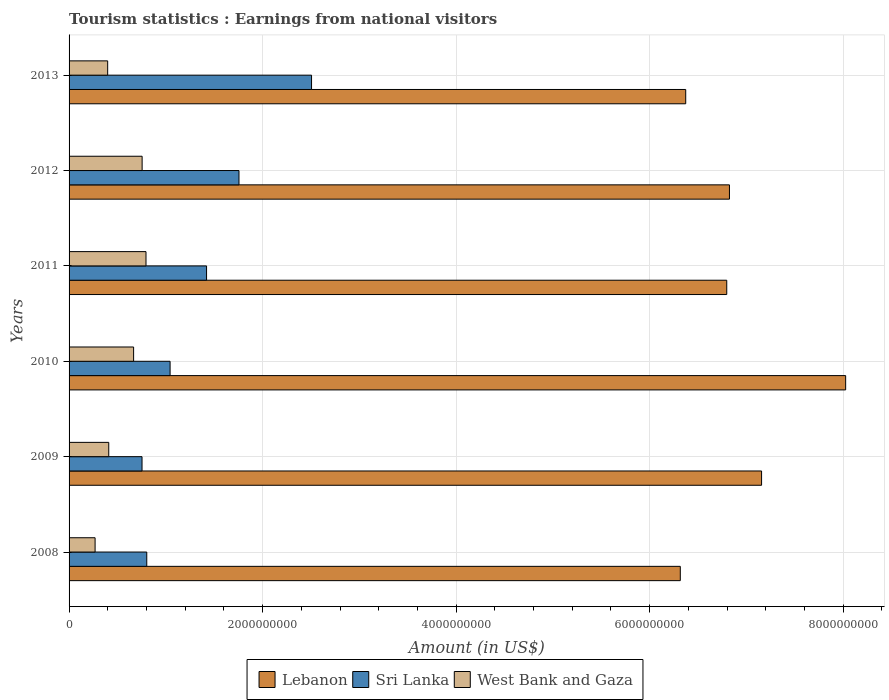Are the number of bars per tick equal to the number of legend labels?
Ensure brevity in your answer.  Yes. How many bars are there on the 4th tick from the top?
Your answer should be compact. 3. How many bars are there on the 2nd tick from the bottom?
Your answer should be very brief. 3. In how many cases, is the number of bars for a given year not equal to the number of legend labels?
Give a very brief answer. 0. What is the earnings from national visitors in West Bank and Gaza in 2012?
Provide a succinct answer. 7.55e+08. Across all years, what is the maximum earnings from national visitors in Lebanon?
Make the answer very short. 8.03e+09. Across all years, what is the minimum earnings from national visitors in Sri Lanka?
Your response must be concise. 7.54e+08. In which year was the earnings from national visitors in Lebanon maximum?
Ensure brevity in your answer.  2010. In which year was the earnings from national visitors in Lebanon minimum?
Make the answer very short. 2008. What is the total earnings from national visitors in Sri Lanka in the graph?
Provide a succinct answer. 8.28e+09. What is the difference between the earnings from national visitors in Sri Lanka in 2009 and that in 2013?
Provide a succinct answer. -1.75e+09. What is the difference between the earnings from national visitors in West Bank and Gaza in 2009 and the earnings from national visitors in Sri Lanka in 2012?
Ensure brevity in your answer.  -1.35e+09. What is the average earnings from national visitors in West Bank and Gaza per year?
Offer a terse response. 5.49e+08. In the year 2012, what is the difference between the earnings from national visitors in West Bank and Gaza and earnings from national visitors in Sri Lanka?
Keep it short and to the point. -1.00e+09. In how many years, is the earnings from national visitors in Sri Lanka greater than 1200000000 US$?
Your answer should be very brief. 3. What is the ratio of the earnings from national visitors in Lebanon in 2009 to that in 2013?
Keep it short and to the point. 1.12. Is the earnings from national visitors in Sri Lanka in 2010 less than that in 2013?
Ensure brevity in your answer.  Yes. What is the difference between the highest and the second highest earnings from national visitors in Sri Lanka?
Your answer should be compact. 7.50e+08. What is the difference between the highest and the lowest earnings from national visitors in West Bank and Gaza?
Offer a very short reply. 5.26e+08. In how many years, is the earnings from national visitors in West Bank and Gaza greater than the average earnings from national visitors in West Bank and Gaza taken over all years?
Make the answer very short. 3. What does the 2nd bar from the top in 2010 represents?
Give a very brief answer. Sri Lanka. What does the 1st bar from the bottom in 2011 represents?
Ensure brevity in your answer.  Lebanon. Is it the case that in every year, the sum of the earnings from national visitors in West Bank and Gaza and earnings from national visitors in Sri Lanka is greater than the earnings from national visitors in Lebanon?
Offer a very short reply. No. How many bars are there?
Your response must be concise. 18. Are all the bars in the graph horizontal?
Offer a very short reply. Yes. Are the values on the major ticks of X-axis written in scientific E-notation?
Keep it short and to the point. No. Where does the legend appear in the graph?
Make the answer very short. Bottom center. How are the legend labels stacked?
Your answer should be very brief. Horizontal. What is the title of the graph?
Provide a short and direct response. Tourism statistics : Earnings from national visitors. What is the label or title of the X-axis?
Provide a short and direct response. Amount (in US$). What is the Amount (in US$) in Lebanon in 2008?
Keep it short and to the point. 6.32e+09. What is the Amount (in US$) in Sri Lanka in 2008?
Your response must be concise. 8.03e+08. What is the Amount (in US$) in West Bank and Gaza in 2008?
Give a very brief answer. 2.69e+08. What is the Amount (in US$) of Lebanon in 2009?
Your response must be concise. 7.16e+09. What is the Amount (in US$) in Sri Lanka in 2009?
Your answer should be compact. 7.54e+08. What is the Amount (in US$) in West Bank and Gaza in 2009?
Keep it short and to the point. 4.10e+08. What is the Amount (in US$) in Lebanon in 2010?
Your answer should be very brief. 8.03e+09. What is the Amount (in US$) of Sri Lanka in 2010?
Your answer should be compact. 1.04e+09. What is the Amount (in US$) of West Bank and Gaza in 2010?
Make the answer very short. 6.67e+08. What is the Amount (in US$) in Lebanon in 2011?
Make the answer very short. 6.80e+09. What is the Amount (in US$) in Sri Lanka in 2011?
Provide a succinct answer. 1.42e+09. What is the Amount (in US$) of West Bank and Gaza in 2011?
Offer a terse response. 7.95e+08. What is the Amount (in US$) of Lebanon in 2012?
Provide a succinct answer. 6.82e+09. What is the Amount (in US$) in Sri Lanka in 2012?
Keep it short and to the point. 1.76e+09. What is the Amount (in US$) of West Bank and Gaza in 2012?
Keep it short and to the point. 7.55e+08. What is the Amount (in US$) in Lebanon in 2013?
Make the answer very short. 6.37e+09. What is the Amount (in US$) of Sri Lanka in 2013?
Your response must be concise. 2.51e+09. What is the Amount (in US$) of West Bank and Gaza in 2013?
Keep it short and to the point. 3.99e+08. Across all years, what is the maximum Amount (in US$) of Lebanon?
Keep it short and to the point. 8.03e+09. Across all years, what is the maximum Amount (in US$) in Sri Lanka?
Offer a terse response. 2.51e+09. Across all years, what is the maximum Amount (in US$) in West Bank and Gaza?
Make the answer very short. 7.95e+08. Across all years, what is the minimum Amount (in US$) in Lebanon?
Offer a terse response. 6.32e+09. Across all years, what is the minimum Amount (in US$) in Sri Lanka?
Offer a terse response. 7.54e+08. Across all years, what is the minimum Amount (in US$) of West Bank and Gaza?
Your response must be concise. 2.69e+08. What is the total Amount (in US$) in Lebanon in the graph?
Ensure brevity in your answer.  4.15e+1. What is the total Amount (in US$) of Sri Lanka in the graph?
Give a very brief answer. 8.28e+09. What is the total Amount (in US$) of West Bank and Gaza in the graph?
Keep it short and to the point. 3.30e+09. What is the difference between the Amount (in US$) in Lebanon in 2008 and that in 2009?
Keep it short and to the point. -8.40e+08. What is the difference between the Amount (in US$) of Sri Lanka in 2008 and that in 2009?
Provide a short and direct response. 4.90e+07. What is the difference between the Amount (in US$) in West Bank and Gaza in 2008 and that in 2009?
Ensure brevity in your answer.  -1.41e+08. What is the difference between the Amount (in US$) of Lebanon in 2008 and that in 2010?
Your answer should be compact. -1.71e+09. What is the difference between the Amount (in US$) in Sri Lanka in 2008 and that in 2010?
Your response must be concise. -2.41e+08. What is the difference between the Amount (in US$) of West Bank and Gaza in 2008 and that in 2010?
Give a very brief answer. -3.98e+08. What is the difference between the Amount (in US$) of Lebanon in 2008 and that in 2011?
Your answer should be compact. -4.80e+08. What is the difference between the Amount (in US$) of Sri Lanka in 2008 and that in 2011?
Provide a short and direct response. -6.18e+08. What is the difference between the Amount (in US$) of West Bank and Gaza in 2008 and that in 2011?
Your response must be concise. -5.26e+08. What is the difference between the Amount (in US$) of Lebanon in 2008 and that in 2012?
Your response must be concise. -5.08e+08. What is the difference between the Amount (in US$) in Sri Lanka in 2008 and that in 2012?
Make the answer very short. -9.53e+08. What is the difference between the Amount (in US$) in West Bank and Gaza in 2008 and that in 2012?
Provide a short and direct response. -4.86e+08. What is the difference between the Amount (in US$) of Lebanon in 2008 and that in 2013?
Offer a very short reply. -5.60e+07. What is the difference between the Amount (in US$) in Sri Lanka in 2008 and that in 2013?
Provide a succinct answer. -1.70e+09. What is the difference between the Amount (in US$) in West Bank and Gaza in 2008 and that in 2013?
Offer a very short reply. -1.30e+08. What is the difference between the Amount (in US$) in Lebanon in 2009 and that in 2010?
Provide a short and direct response. -8.69e+08. What is the difference between the Amount (in US$) of Sri Lanka in 2009 and that in 2010?
Ensure brevity in your answer.  -2.90e+08. What is the difference between the Amount (in US$) of West Bank and Gaza in 2009 and that in 2010?
Keep it short and to the point. -2.57e+08. What is the difference between the Amount (in US$) of Lebanon in 2009 and that in 2011?
Your answer should be very brief. 3.60e+08. What is the difference between the Amount (in US$) of Sri Lanka in 2009 and that in 2011?
Ensure brevity in your answer.  -6.67e+08. What is the difference between the Amount (in US$) of West Bank and Gaza in 2009 and that in 2011?
Give a very brief answer. -3.85e+08. What is the difference between the Amount (in US$) in Lebanon in 2009 and that in 2012?
Offer a very short reply. 3.32e+08. What is the difference between the Amount (in US$) in Sri Lanka in 2009 and that in 2012?
Provide a short and direct response. -1.00e+09. What is the difference between the Amount (in US$) in West Bank and Gaza in 2009 and that in 2012?
Provide a succinct answer. -3.45e+08. What is the difference between the Amount (in US$) of Lebanon in 2009 and that in 2013?
Your answer should be compact. 7.84e+08. What is the difference between the Amount (in US$) of Sri Lanka in 2009 and that in 2013?
Offer a terse response. -1.75e+09. What is the difference between the Amount (in US$) of West Bank and Gaza in 2009 and that in 2013?
Your answer should be very brief. 1.10e+07. What is the difference between the Amount (in US$) of Lebanon in 2010 and that in 2011?
Give a very brief answer. 1.23e+09. What is the difference between the Amount (in US$) in Sri Lanka in 2010 and that in 2011?
Your answer should be compact. -3.77e+08. What is the difference between the Amount (in US$) in West Bank and Gaza in 2010 and that in 2011?
Give a very brief answer. -1.28e+08. What is the difference between the Amount (in US$) of Lebanon in 2010 and that in 2012?
Your answer should be compact. 1.20e+09. What is the difference between the Amount (in US$) in Sri Lanka in 2010 and that in 2012?
Give a very brief answer. -7.12e+08. What is the difference between the Amount (in US$) of West Bank and Gaza in 2010 and that in 2012?
Make the answer very short. -8.80e+07. What is the difference between the Amount (in US$) in Lebanon in 2010 and that in 2013?
Offer a very short reply. 1.65e+09. What is the difference between the Amount (in US$) of Sri Lanka in 2010 and that in 2013?
Ensure brevity in your answer.  -1.46e+09. What is the difference between the Amount (in US$) of West Bank and Gaza in 2010 and that in 2013?
Give a very brief answer. 2.68e+08. What is the difference between the Amount (in US$) in Lebanon in 2011 and that in 2012?
Ensure brevity in your answer.  -2.80e+07. What is the difference between the Amount (in US$) of Sri Lanka in 2011 and that in 2012?
Provide a succinct answer. -3.35e+08. What is the difference between the Amount (in US$) in West Bank and Gaza in 2011 and that in 2012?
Provide a succinct answer. 4.00e+07. What is the difference between the Amount (in US$) in Lebanon in 2011 and that in 2013?
Keep it short and to the point. 4.24e+08. What is the difference between the Amount (in US$) of Sri Lanka in 2011 and that in 2013?
Make the answer very short. -1.08e+09. What is the difference between the Amount (in US$) of West Bank and Gaza in 2011 and that in 2013?
Provide a short and direct response. 3.96e+08. What is the difference between the Amount (in US$) of Lebanon in 2012 and that in 2013?
Make the answer very short. 4.52e+08. What is the difference between the Amount (in US$) in Sri Lanka in 2012 and that in 2013?
Keep it short and to the point. -7.50e+08. What is the difference between the Amount (in US$) in West Bank and Gaza in 2012 and that in 2013?
Your answer should be compact. 3.56e+08. What is the difference between the Amount (in US$) of Lebanon in 2008 and the Amount (in US$) of Sri Lanka in 2009?
Your answer should be very brief. 5.56e+09. What is the difference between the Amount (in US$) of Lebanon in 2008 and the Amount (in US$) of West Bank and Gaza in 2009?
Your answer should be very brief. 5.91e+09. What is the difference between the Amount (in US$) of Sri Lanka in 2008 and the Amount (in US$) of West Bank and Gaza in 2009?
Your answer should be very brief. 3.93e+08. What is the difference between the Amount (in US$) in Lebanon in 2008 and the Amount (in US$) in Sri Lanka in 2010?
Your answer should be compact. 5.27e+09. What is the difference between the Amount (in US$) of Lebanon in 2008 and the Amount (in US$) of West Bank and Gaza in 2010?
Ensure brevity in your answer.  5.65e+09. What is the difference between the Amount (in US$) in Sri Lanka in 2008 and the Amount (in US$) in West Bank and Gaza in 2010?
Make the answer very short. 1.36e+08. What is the difference between the Amount (in US$) of Lebanon in 2008 and the Amount (in US$) of Sri Lanka in 2011?
Give a very brief answer. 4.90e+09. What is the difference between the Amount (in US$) of Lebanon in 2008 and the Amount (in US$) of West Bank and Gaza in 2011?
Provide a short and direct response. 5.52e+09. What is the difference between the Amount (in US$) of Sri Lanka in 2008 and the Amount (in US$) of West Bank and Gaza in 2011?
Your response must be concise. 8.00e+06. What is the difference between the Amount (in US$) in Lebanon in 2008 and the Amount (in US$) in Sri Lanka in 2012?
Your answer should be compact. 4.56e+09. What is the difference between the Amount (in US$) of Lebanon in 2008 and the Amount (in US$) of West Bank and Gaza in 2012?
Make the answer very short. 5.56e+09. What is the difference between the Amount (in US$) in Sri Lanka in 2008 and the Amount (in US$) in West Bank and Gaza in 2012?
Keep it short and to the point. 4.80e+07. What is the difference between the Amount (in US$) in Lebanon in 2008 and the Amount (in US$) in Sri Lanka in 2013?
Ensure brevity in your answer.  3.81e+09. What is the difference between the Amount (in US$) of Lebanon in 2008 and the Amount (in US$) of West Bank and Gaza in 2013?
Ensure brevity in your answer.  5.92e+09. What is the difference between the Amount (in US$) in Sri Lanka in 2008 and the Amount (in US$) in West Bank and Gaza in 2013?
Keep it short and to the point. 4.04e+08. What is the difference between the Amount (in US$) of Lebanon in 2009 and the Amount (in US$) of Sri Lanka in 2010?
Make the answer very short. 6.11e+09. What is the difference between the Amount (in US$) in Lebanon in 2009 and the Amount (in US$) in West Bank and Gaza in 2010?
Your answer should be very brief. 6.49e+09. What is the difference between the Amount (in US$) of Sri Lanka in 2009 and the Amount (in US$) of West Bank and Gaza in 2010?
Make the answer very short. 8.70e+07. What is the difference between the Amount (in US$) in Lebanon in 2009 and the Amount (in US$) in Sri Lanka in 2011?
Your answer should be very brief. 5.74e+09. What is the difference between the Amount (in US$) in Lebanon in 2009 and the Amount (in US$) in West Bank and Gaza in 2011?
Provide a succinct answer. 6.36e+09. What is the difference between the Amount (in US$) in Sri Lanka in 2009 and the Amount (in US$) in West Bank and Gaza in 2011?
Your answer should be very brief. -4.10e+07. What is the difference between the Amount (in US$) of Lebanon in 2009 and the Amount (in US$) of Sri Lanka in 2012?
Your response must be concise. 5.40e+09. What is the difference between the Amount (in US$) in Lebanon in 2009 and the Amount (in US$) in West Bank and Gaza in 2012?
Offer a very short reply. 6.40e+09. What is the difference between the Amount (in US$) of Lebanon in 2009 and the Amount (in US$) of Sri Lanka in 2013?
Give a very brief answer. 4.65e+09. What is the difference between the Amount (in US$) of Lebanon in 2009 and the Amount (in US$) of West Bank and Gaza in 2013?
Offer a terse response. 6.76e+09. What is the difference between the Amount (in US$) of Sri Lanka in 2009 and the Amount (in US$) of West Bank and Gaza in 2013?
Offer a very short reply. 3.55e+08. What is the difference between the Amount (in US$) in Lebanon in 2010 and the Amount (in US$) in Sri Lanka in 2011?
Offer a terse response. 6.60e+09. What is the difference between the Amount (in US$) in Lebanon in 2010 and the Amount (in US$) in West Bank and Gaza in 2011?
Offer a very short reply. 7.23e+09. What is the difference between the Amount (in US$) in Sri Lanka in 2010 and the Amount (in US$) in West Bank and Gaza in 2011?
Give a very brief answer. 2.49e+08. What is the difference between the Amount (in US$) in Lebanon in 2010 and the Amount (in US$) in Sri Lanka in 2012?
Give a very brief answer. 6.27e+09. What is the difference between the Amount (in US$) of Lebanon in 2010 and the Amount (in US$) of West Bank and Gaza in 2012?
Make the answer very short. 7.27e+09. What is the difference between the Amount (in US$) in Sri Lanka in 2010 and the Amount (in US$) in West Bank and Gaza in 2012?
Make the answer very short. 2.89e+08. What is the difference between the Amount (in US$) of Lebanon in 2010 and the Amount (in US$) of Sri Lanka in 2013?
Offer a terse response. 5.52e+09. What is the difference between the Amount (in US$) in Lebanon in 2010 and the Amount (in US$) in West Bank and Gaza in 2013?
Provide a succinct answer. 7.63e+09. What is the difference between the Amount (in US$) of Sri Lanka in 2010 and the Amount (in US$) of West Bank and Gaza in 2013?
Provide a succinct answer. 6.45e+08. What is the difference between the Amount (in US$) in Lebanon in 2011 and the Amount (in US$) in Sri Lanka in 2012?
Keep it short and to the point. 5.04e+09. What is the difference between the Amount (in US$) of Lebanon in 2011 and the Amount (in US$) of West Bank and Gaza in 2012?
Offer a very short reply. 6.04e+09. What is the difference between the Amount (in US$) in Sri Lanka in 2011 and the Amount (in US$) in West Bank and Gaza in 2012?
Your answer should be very brief. 6.66e+08. What is the difference between the Amount (in US$) of Lebanon in 2011 and the Amount (in US$) of Sri Lanka in 2013?
Offer a very short reply. 4.29e+09. What is the difference between the Amount (in US$) of Lebanon in 2011 and the Amount (in US$) of West Bank and Gaza in 2013?
Your answer should be very brief. 6.40e+09. What is the difference between the Amount (in US$) of Sri Lanka in 2011 and the Amount (in US$) of West Bank and Gaza in 2013?
Your answer should be compact. 1.02e+09. What is the difference between the Amount (in US$) in Lebanon in 2012 and the Amount (in US$) in Sri Lanka in 2013?
Ensure brevity in your answer.  4.32e+09. What is the difference between the Amount (in US$) in Lebanon in 2012 and the Amount (in US$) in West Bank and Gaza in 2013?
Offer a terse response. 6.43e+09. What is the difference between the Amount (in US$) in Sri Lanka in 2012 and the Amount (in US$) in West Bank and Gaza in 2013?
Offer a very short reply. 1.36e+09. What is the average Amount (in US$) in Lebanon per year?
Offer a very short reply. 6.92e+09. What is the average Amount (in US$) of Sri Lanka per year?
Provide a succinct answer. 1.38e+09. What is the average Amount (in US$) of West Bank and Gaza per year?
Provide a succinct answer. 5.49e+08. In the year 2008, what is the difference between the Amount (in US$) in Lebanon and Amount (in US$) in Sri Lanka?
Offer a very short reply. 5.51e+09. In the year 2008, what is the difference between the Amount (in US$) of Lebanon and Amount (in US$) of West Bank and Gaza?
Your answer should be compact. 6.05e+09. In the year 2008, what is the difference between the Amount (in US$) of Sri Lanka and Amount (in US$) of West Bank and Gaza?
Offer a very short reply. 5.34e+08. In the year 2009, what is the difference between the Amount (in US$) of Lebanon and Amount (in US$) of Sri Lanka?
Ensure brevity in your answer.  6.40e+09. In the year 2009, what is the difference between the Amount (in US$) in Lebanon and Amount (in US$) in West Bank and Gaza?
Ensure brevity in your answer.  6.75e+09. In the year 2009, what is the difference between the Amount (in US$) of Sri Lanka and Amount (in US$) of West Bank and Gaza?
Offer a terse response. 3.44e+08. In the year 2010, what is the difference between the Amount (in US$) of Lebanon and Amount (in US$) of Sri Lanka?
Provide a short and direct response. 6.98e+09. In the year 2010, what is the difference between the Amount (in US$) in Lebanon and Amount (in US$) in West Bank and Gaza?
Provide a short and direct response. 7.36e+09. In the year 2010, what is the difference between the Amount (in US$) of Sri Lanka and Amount (in US$) of West Bank and Gaza?
Provide a short and direct response. 3.77e+08. In the year 2011, what is the difference between the Amount (in US$) of Lebanon and Amount (in US$) of Sri Lanka?
Ensure brevity in your answer.  5.38e+09. In the year 2011, what is the difference between the Amount (in US$) in Lebanon and Amount (in US$) in West Bank and Gaza?
Offer a very short reply. 6.00e+09. In the year 2011, what is the difference between the Amount (in US$) of Sri Lanka and Amount (in US$) of West Bank and Gaza?
Keep it short and to the point. 6.26e+08. In the year 2012, what is the difference between the Amount (in US$) in Lebanon and Amount (in US$) in Sri Lanka?
Offer a very short reply. 5.07e+09. In the year 2012, what is the difference between the Amount (in US$) in Lebanon and Amount (in US$) in West Bank and Gaza?
Keep it short and to the point. 6.07e+09. In the year 2012, what is the difference between the Amount (in US$) of Sri Lanka and Amount (in US$) of West Bank and Gaza?
Offer a terse response. 1.00e+09. In the year 2013, what is the difference between the Amount (in US$) in Lebanon and Amount (in US$) in Sri Lanka?
Your answer should be very brief. 3.87e+09. In the year 2013, what is the difference between the Amount (in US$) in Lebanon and Amount (in US$) in West Bank and Gaza?
Keep it short and to the point. 5.97e+09. In the year 2013, what is the difference between the Amount (in US$) in Sri Lanka and Amount (in US$) in West Bank and Gaza?
Make the answer very short. 2.11e+09. What is the ratio of the Amount (in US$) of Lebanon in 2008 to that in 2009?
Offer a terse response. 0.88. What is the ratio of the Amount (in US$) in Sri Lanka in 2008 to that in 2009?
Provide a short and direct response. 1.06. What is the ratio of the Amount (in US$) of West Bank and Gaza in 2008 to that in 2009?
Your response must be concise. 0.66. What is the ratio of the Amount (in US$) in Lebanon in 2008 to that in 2010?
Make the answer very short. 0.79. What is the ratio of the Amount (in US$) in Sri Lanka in 2008 to that in 2010?
Offer a very short reply. 0.77. What is the ratio of the Amount (in US$) in West Bank and Gaza in 2008 to that in 2010?
Make the answer very short. 0.4. What is the ratio of the Amount (in US$) of Lebanon in 2008 to that in 2011?
Your answer should be compact. 0.93. What is the ratio of the Amount (in US$) in Sri Lanka in 2008 to that in 2011?
Keep it short and to the point. 0.57. What is the ratio of the Amount (in US$) of West Bank and Gaza in 2008 to that in 2011?
Keep it short and to the point. 0.34. What is the ratio of the Amount (in US$) of Lebanon in 2008 to that in 2012?
Ensure brevity in your answer.  0.93. What is the ratio of the Amount (in US$) in Sri Lanka in 2008 to that in 2012?
Your answer should be compact. 0.46. What is the ratio of the Amount (in US$) in West Bank and Gaza in 2008 to that in 2012?
Keep it short and to the point. 0.36. What is the ratio of the Amount (in US$) in Sri Lanka in 2008 to that in 2013?
Provide a succinct answer. 0.32. What is the ratio of the Amount (in US$) in West Bank and Gaza in 2008 to that in 2013?
Offer a very short reply. 0.67. What is the ratio of the Amount (in US$) of Lebanon in 2009 to that in 2010?
Give a very brief answer. 0.89. What is the ratio of the Amount (in US$) of Sri Lanka in 2009 to that in 2010?
Offer a terse response. 0.72. What is the ratio of the Amount (in US$) in West Bank and Gaza in 2009 to that in 2010?
Provide a succinct answer. 0.61. What is the ratio of the Amount (in US$) in Lebanon in 2009 to that in 2011?
Your response must be concise. 1.05. What is the ratio of the Amount (in US$) of Sri Lanka in 2009 to that in 2011?
Ensure brevity in your answer.  0.53. What is the ratio of the Amount (in US$) of West Bank and Gaza in 2009 to that in 2011?
Your answer should be very brief. 0.52. What is the ratio of the Amount (in US$) in Lebanon in 2009 to that in 2012?
Make the answer very short. 1.05. What is the ratio of the Amount (in US$) of Sri Lanka in 2009 to that in 2012?
Offer a terse response. 0.43. What is the ratio of the Amount (in US$) of West Bank and Gaza in 2009 to that in 2012?
Provide a short and direct response. 0.54. What is the ratio of the Amount (in US$) of Lebanon in 2009 to that in 2013?
Keep it short and to the point. 1.12. What is the ratio of the Amount (in US$) in Sri Lanka in 2009 to that in 2013?
Provide a succinct answer. 0.3. What is the ratio of the Amount (in US$) of West Bank and Gaza in 2009 to that in 2013?
Offer a very short reply. 1.03. What is the ratio of the Amount (in US$) of Lebanon in 2010 to that in 2011?
Make the answer very short. 1.18. What is the ratio of the Amount (in US$) in Sri Lanka in 2010 to that in 2011?
Offer a terse response. 0.73. What is the ratio of the Amount (in US$) of West Bank and Gaza in 2010 to that in 2011?
Give a very brief answer. 0.84. What is the ratio of the Amount (in US$) of Lebanon in 2010 to that in 2012?
Offer a very short reply. 1.18. What is the ratio of the Amount (in US$) in Sri Lanka in 2010 to that in 2012?
Keep it short and to the point. 0.59. What is the ratio of the Amount (in US$) of West Bank and Gaza in 2010 to that in 2012?
Your response must be concise. 0.88. What is the ratio of the Amount (in US$) of Lebanon in 2010 to that in 2013?
Make the answer very short. 1.26. What is the ratio of the Amount (in US$) of Sri Lanka in 2010 to that in 2013?
Offer a terse response. 0.42. What is the ratio of the Amount (in US$) in West Bank and Gaza in 2010 to that in 2013?
Keep it short and to the point. 1.67. What is the ratio of the Amount (in US$) of Sri Lanka in 2011 to that in 2012?
Offer a very short reply. 0.81. What is the ratio of the Amount (in US$) of West Bank and Gaza in 2011 to that in 2012?
Provide a succinct answer. 1.05. What is the ratio of the Amount (in US$) in Lebanon in 2011 to that in 2013?
Provide a succinct answer. 1.07. What is the ratio of the Amount (in US$) in Sri Lanka in 2011 to that in 2013?
Offer a terse response. 0.57. What is the ratio of the Amount (in US$) in West Bank and Gaza in 2011 to that in 2013?
Ensure brevity in your answer.  1.99. What is the ratio of the Amount (in US$) of Lebanon in 2012 to that in 2013?
Keep it short and to the point. 1.07. What is the ratio of the Amount (in US$) in Sri Lanka in 2012 to that in 2013?
Give a very brief answer. 0.7. What is the ratio of the Amount (in US$) of West Bank and Gaza in 2012 to that in 2013?
Ensure brevity in your answer.  1.89. What is the difference between the highest and the second highest Amount (in US$) in Lebanon?
Offer a terse response. 8.69e+08. What is the difference between the highest and the second highest Amount (in US$) of Sri Lanka?
Ensure brevity in your answer.  7.50e+08. What is the difference between the highest and the second highest Amount (in US$) in West Bank and Gaza?
Your response must be concise. 4.00e+07. What is the difference between the highest and the lowest Amount (in US$) of Lebanon?
Keep it short and to the point. 1.71e+09. What is the difference between the highest and the lowest Amount (in US$) of Sri Lanka?
Give a very brief answer. 1.75e+09. What is the difference between the highest and the lowest Amount (in US$) in West Bank and Gaza?
Make the answer very short. 5.26e+08. 